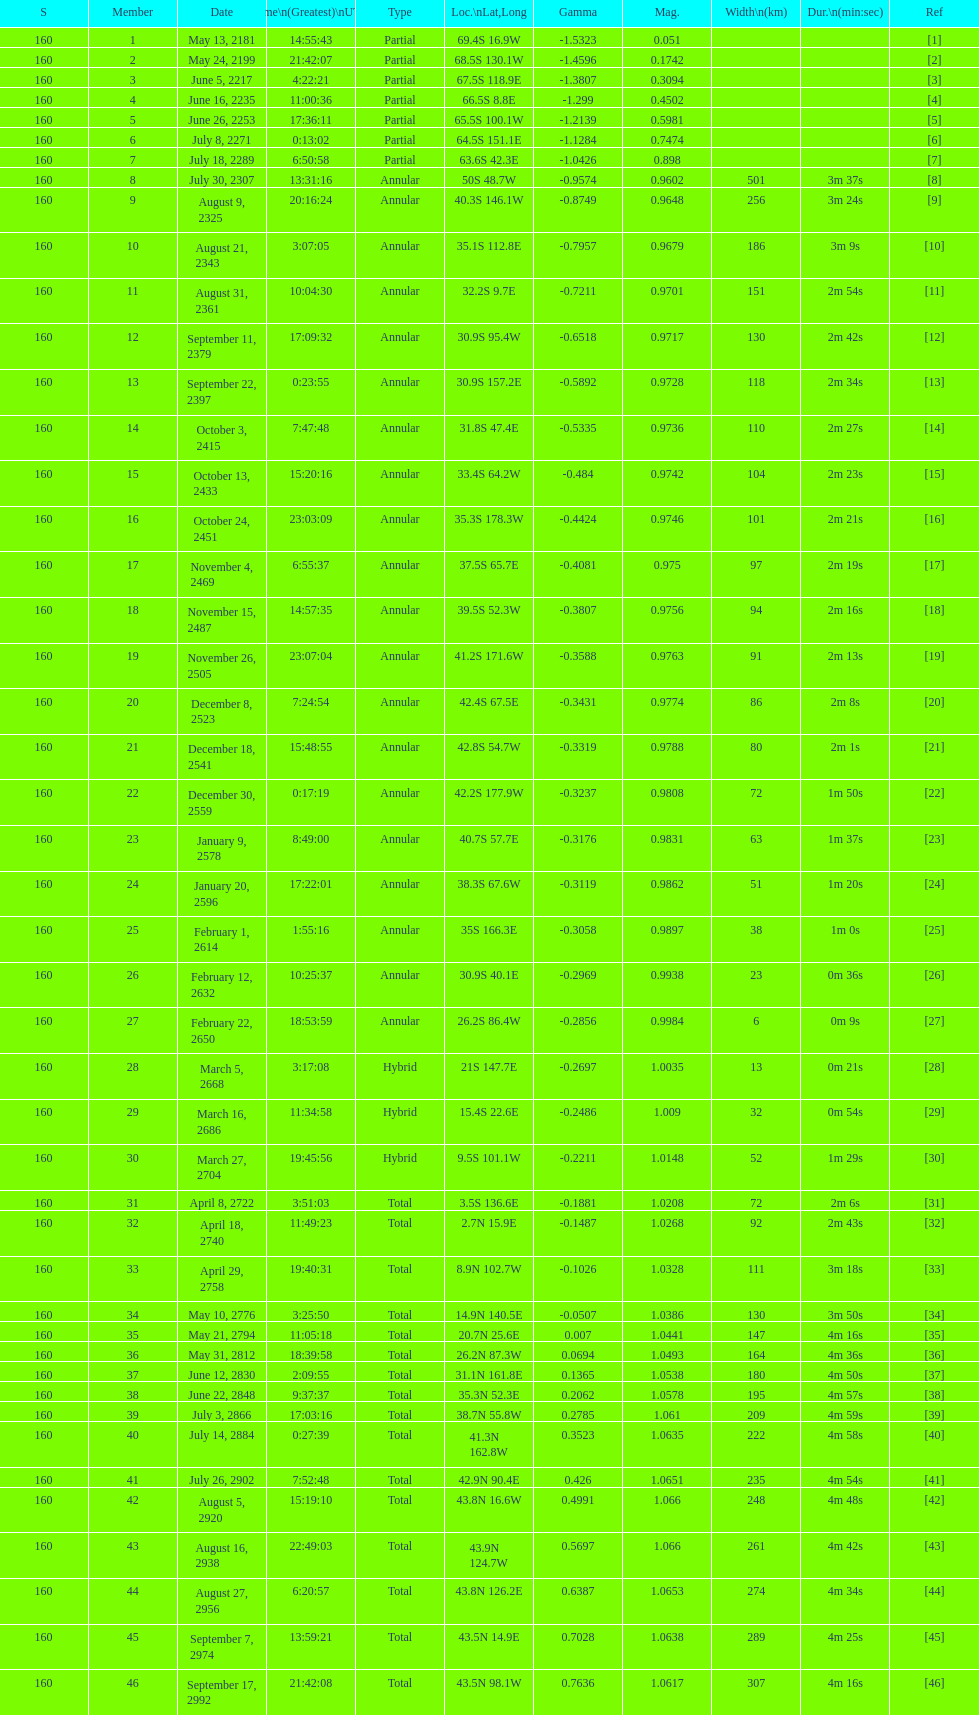Give me the full table as a dictionary. {'header': ['S', 'Member', 'Date', 'Time\\n(Greatest)\\nUTC', 'Type', 'Loc.\\nLat,Long', 'Gamma', 'Mag.', 'Width\\n(km)', 'Dur.\\n(min:sec)', 'Ref'], 'rows': [['160', '1', 'May 13, 2181', '14:55:43', 'Partial', '69.4S 16.9W', '-1.5323', '0.051', '', '', '[1]'], ['160', '2', 'May 24, 2199', '21:42:07', 'Partial', '68.5S 130.1W', '-1.4596', '0.1742', '', '', '[2]'], ['160', '3', 'June 5, 2217', '4:22:21', 'Partial', '67.5S 118.9E', '-1.3807', '0.3094', '', '', '[3]'], ['160', '4', 'June 16, 2235', '11:00:36', 'Partial', '66.5S 8.8E', '-1.299', '0.4502', '', '', '[4]'], ['160', '5', 'June 26, 2253', '17:36:11', 'Partial', '65.5S 100.1W', '-1.2139', '0.5981', '', '', '[5]'], ['160', '6', 'July 8, 2271', '0:13:02', 'Partial', '64.5S 151.1E', '-1.1284', '0.7474', '', '', '[6]'], ['160', '7', 'July 18, 2289', '6:50:58', 'Partial', '63.6S 42.3E', '-1.0426', '0.898', '', '', '[7]'], ['160', '8', 'July 30, 2307', '13:31:16', 'Annular', '50S 48.7W', '-0.9574', '0.9602', '501', '3m 37s', '[8]'], ['160', '9', 'August 9, 2325', '20:16:24', 'Annular', '40.3S 146.1W', '-0.8749', '0.9648', '256', '3m 24s', '[9]'], ['160', '10', 'August 21, 2343', '3:07:05', 'Annular', '35.1S 112.8E', '-0.7957', '0.9679', '186', '3m 9s', '[10]'], ['160', '11', 'August 31, 2361', '10:04:30', 'Annular', '32.2S 9.7E', '-0.7211', '0.9701', '151', '2m 54s', '[11]'], ['160', '12', 'September 11, 2379', '17:09:32', 'Annular', '30.9S 95.4W', '-0.6518', '0.9717', '130', '2m 42s', '[12]'], ['160', '13', 'September 22, 2397', '0:23:55', 'Annular', '30.9S 157.2E', '-0.5892', '0.9728', '118', '2m 34s', '[13]'], ['160', '14', 'October 3, 2415', '7:47:48', 'Annular', '31.8S 47.4E', '-0.5335', '0.9736', '110', '2m 27s', '[14]'], ['160', '15', 'October 13, 2433', '15:20:16', 'Annular', '33.4S 64.2W', '-0.484', '0.9742', '104', '2m 23s', '[15]'], ['160', '16', 'October 24, 2451', '23:03:09', 'Annular', '35.3S 178.3W', '-0.4424', '0.9746', '101', '2m 21s', '[16]'], ['160', '17', 'November 4, 2469', '6:55:37', 'Annular', '37.5S 65.7E', '-0.4081', '0.975', '97', '2m 19s', '[17]'], ['160', '18', 'November 15, 2487', '14:57:35', 'Annular', '39.5S 52.3W', '-0.3807', '0.9756', '94', '2m 16s', '[18]'], ['160', '19', 'November 26, 2505', '23:07:04', 'Annular', '41.2S 171.6W', '-0.3588', '0.9763', '91', '2m 13s', '[19]'], ['160', '20', 'December 8, 2523', '7:24:54', 'Annular', '42.4S 67.5E', '-0.3431', '0.9774', '86', '2m 8s', '[20]'], ['160', '21', 'December 18, 2541', '15:48:55', 'Annular', '42.8S 54.7W', '-0.3319', '0.9788', '80', '2m 1s', '[21]'], ['160', '22', 'December 30, 2559', '0:17:19', 'Annular', '42.2S 177.9W', '-0.3237', '0.9808', '72', '1m 50s', '[22]'], ['160', '23', 'January 9, 2578', '8:49:00', 'Annular', '40.7S 57.7E', '-0.3176', '0.9831', '63', '1m 37s', '[23]'], ['160', '24', 'January 20, 2596', '17:22:01', 'Annular', '38.3S 67.6W', '-0.3119', '0.9862', '51', '1m 20s', '[24]'], ['160', '25', 'February 1, 2614', '1:55:16', 'Annular', '35S 166.3E', '-0.3058', '0.9897', '38', '1m 0s', '[25]'], ['160', '26', 'February 12, 2632', '10:25:37', 'Annular', '30.9S 40.1E', '-0.2969', '0.9938', '23', '0m 36s', '[26]'], ['160', '27', 'February 22, 2650', '18:53:59', 'Annular', '26.2S 86.4W', '-0.2856', '0.9984', '6', '0m 9s', '[27]'], ['160', '28', 'March 5, 2668', '3:17:08', 'Hybrid', '21S 147.7E', '-0.2697', '1.0035', '13', '0m 21s', '[28]'], ['160', '29', 'March 16, 2686', '11:34:58', 'Hybrid', '15.4S 22.6E', '-0.2486', '1.009', '32', '0m 54s', '[29]'], ['160', '30', 'March 27, 2704', '19:45:56', 'Hybrid', '9.5S 101.1W', '-0.2211', '1.0148', '52', '1m 29s', '[30]'], ['160', '31', 'April 8, 2722', '3:51:03', 'Total', '3.5S 136.6E', '-0.1881', '1.0208', '72', '2m 6s', '[31]'], ['160', '32', 'April 18, 2740', '11:49:23', 'Total', '2.7N 15.9E', '-0.1487', '1.0268', '92', '2m 43s', '[32]'], ['160', '33', 'April 29, 2758', '19:40:31', 'Total', '8.9N 102.7W', '-0.1026', '1.0328', '111', '3m 18s', '[33]'], ['160', '34', 'May 10, 2776', '3:25:50', 'Total', '14.9N 140.5E', '-0.0507', '1.0386', '130', '3m 50s', '[34]'], ['160', '35', 'May 21, 2794', '11:05:18', 'Total', '20.7N 25.6E', '0.007', '1.0441', '147', '4m 16s', '[35]'], ['160', '36', 'May 31, 2812', '18:39:58', 'Total', '26.2N 87.3W', '0.0694', '1.0493', '164', '4m 36s', '[36]'], ['160', '37', 'June 12, 2830', '2:09:55', 'Total', '31.1N 161.8E', '0.1365', '1.0538', '180', '4m 50s', '[37]'], ['160', '38', 'June 22, 2848', '9:37:37', 'Total', '35.3N 52.3E', '0.2062', '1.0578', '195', '4m 57s', '[38]'], ['160', '39', 'July 3, 2866', '17:03:16', 'Total', '38.7N 55.8W', '0.2785', '1.061', '209', '4m 59s', '[39]'], ['160', '40', 'July 14, 2884', '0:27:39', 'Total', '41.3N 162.8W', '0.3523', '1.0635', '222', '4m 58s', '[40]'], ['160', '41', 'July 26, 2902', '7:52:48', 'Total', '42.9N 90.4E', '0.426', '1.0651', '235', '4m 54s', '[41]'], ['160', '42', 'August 5, 2920', '15:19:10', 'Total', '43.8N 16.6W', '0.4991', '1.066', '248', '4m 48s', '[42]'], ['160', '43', 'August 16, 2938', '22:49:03', 'Total', '43.9N 124.7W', '0.5697', '1.066', '261', '4m 42s', '[43]'], ['160', '44', 'August 27, 2956', '6:20:57', 'Total', '43.8N 126.2E', '0.6387', '1.0653', '274', '4m 34s', '[44]'], ['160', '45', 'September 7, 2974', '13:59:21', 'Total', '43.5N 14.9E', '0.7028', '1.0638', '289', '4m 25s', '[45]'], ['160', '46', 'September 17, 2992', '21:42:08', 'Total', '43.5N 98.1W', '0.7636', '1.0617', '307', '4m 16s', '[46]']]} How many partial members will occur before the first annular? 7. 